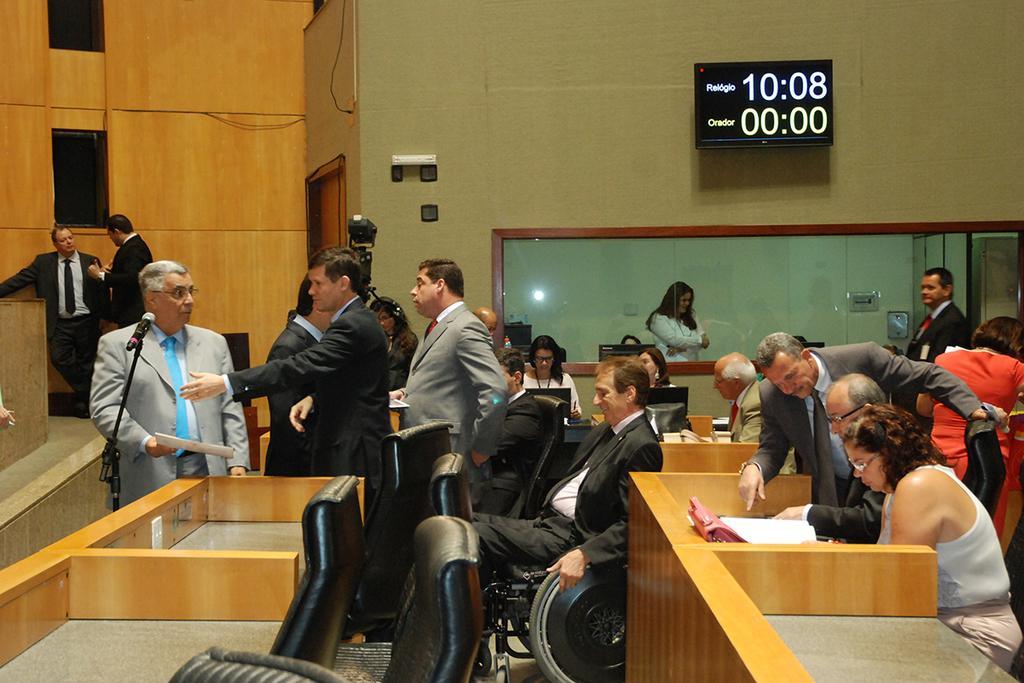Please provide a concise description of this image. In the picture we can find some people are standing and some people are sitting in the background we can find a wall, a glass board and clock, and we also see some chairs and microphones and the people who are standing blazers, ties and shirts. 